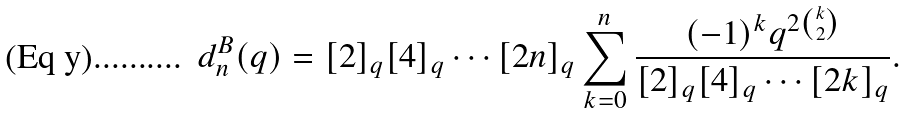<formula> <loc_0><loc_0><loc_500><loc_500>d _ { n } ^ { B } ( q ) = [ 2 ] _ { q } [ 4 ] _ { q } \cdots [ 2 n ] _ { q } \sum _ { k = 0 } ^ { n } \frac { ( - 1 ) ^ { k } q ^ { 2 { k \choose 2 } } } { [ 2 ] _ { q } [ 4 ] _ { q } \cdots [ 2 k ] _ { q } } .</formula> 